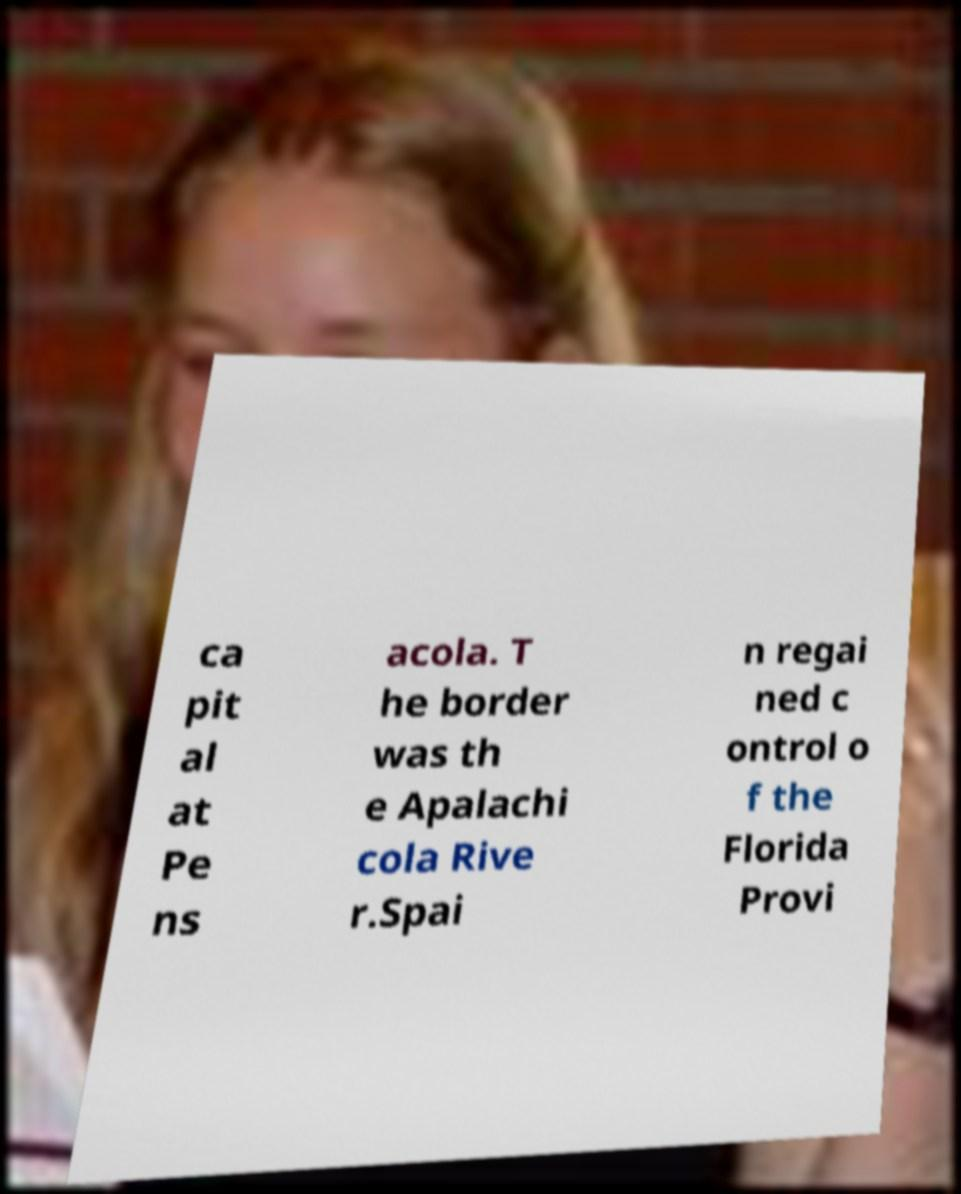Could you extract and type out the text from this image? ca pit al at Pe ns acola. T he border was th e Apalachi cola Rive r.Spai n regai ned c ontrol o f the Florida Provi 